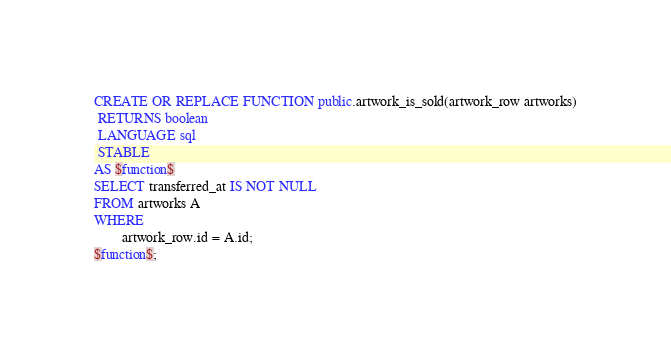Convert code to text. <code><loc_0><loc_0><loc_500><loc_500><_SQL_>CREATE OR REPLACE FUNCTION public.artwork_is_sold(artwork_row artworks)
 RETURNS boolean
 LANGUAGE sql
 STABLE
AS $function$
SELECT transferred_at IS NOT NULL
FROM artworks A
WHERE
        artwork_row.id = A.id;
$function$;
</code> 